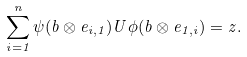Convert formula to latex. <formula><loc_0><loc_0><loc_500><loc_500>\sum _ { i = 1 } ^ { n } \psi ( b \otimes e _ { i , 1 } ) U \phi ( b \otimes e _ { 1 , i } ) = z .</formula> 